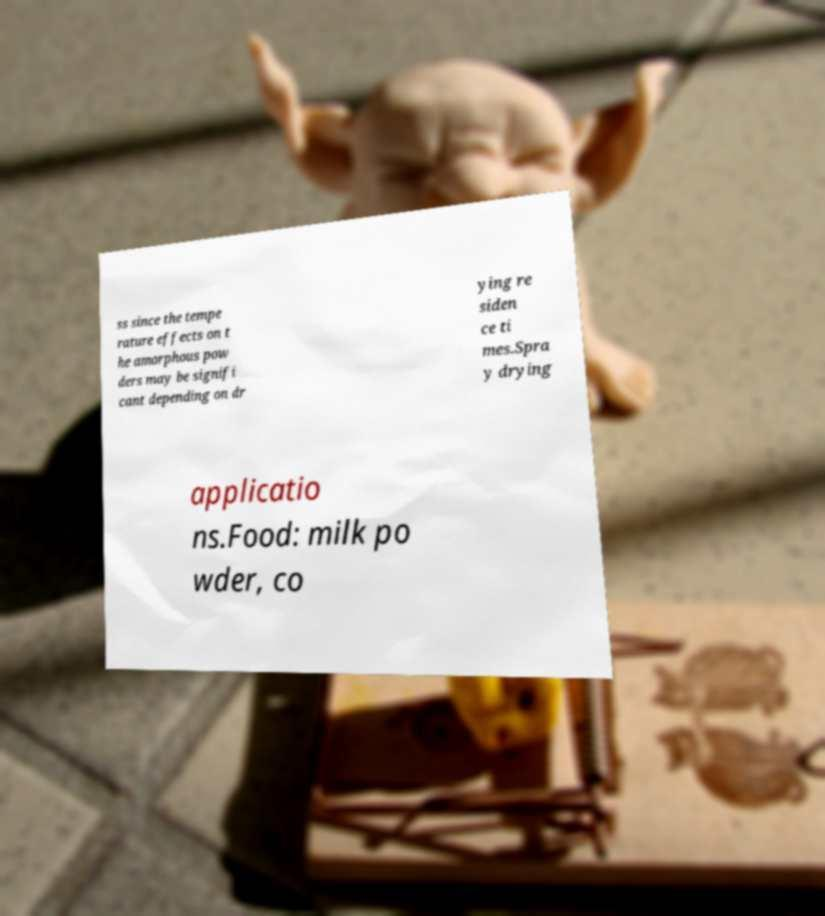Could you extract and type out the text from this image? ss since the tempe rature effects on t he amorphous pow ders may be signifi cant depending on dr ying re siden ce ti mes.Spra y drying applicatio ns.Food: milk po wder, co 